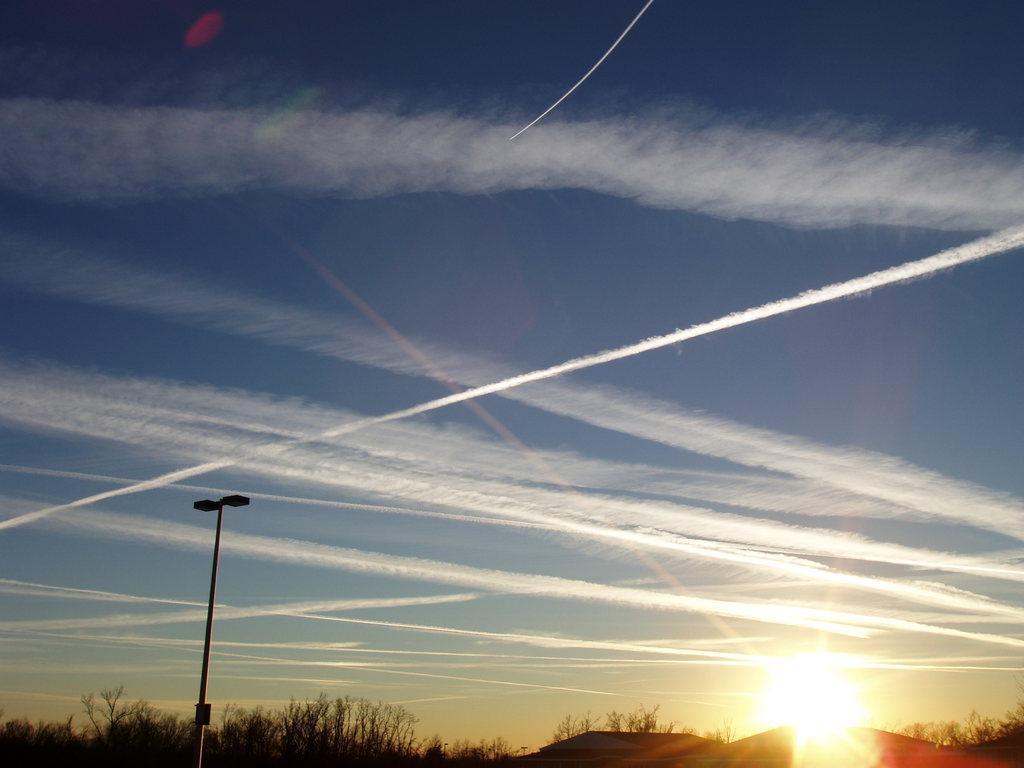Please provide a concise description of this image. In this picture we can see a pole and trees. In the background there is sky. 